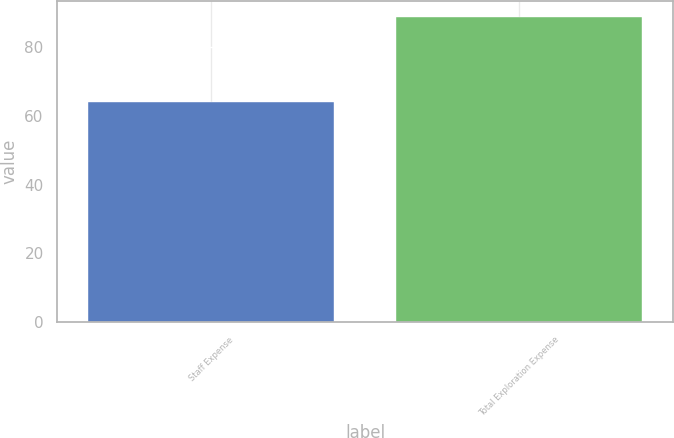<chart> <loc_0><loc_0><loc_500><loc_500><bar_chart><fcel>Staff Expense<fcel>Total Exploration Expense<nl><fcel>64<fcel>89<nl></chart> 